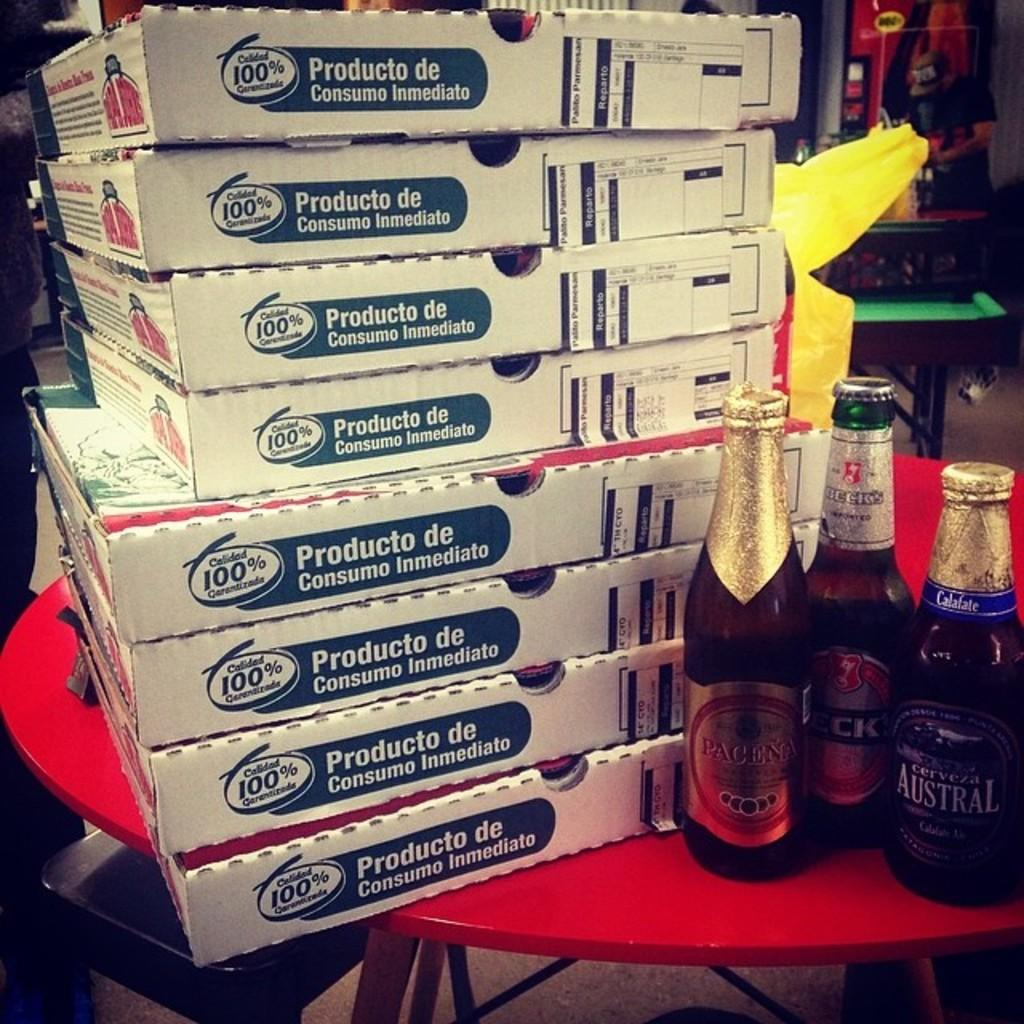<image>
Relay a brief, clear account of the picture shown. 8 Papa Johns Pizza boxes are stacked on top of each other. 